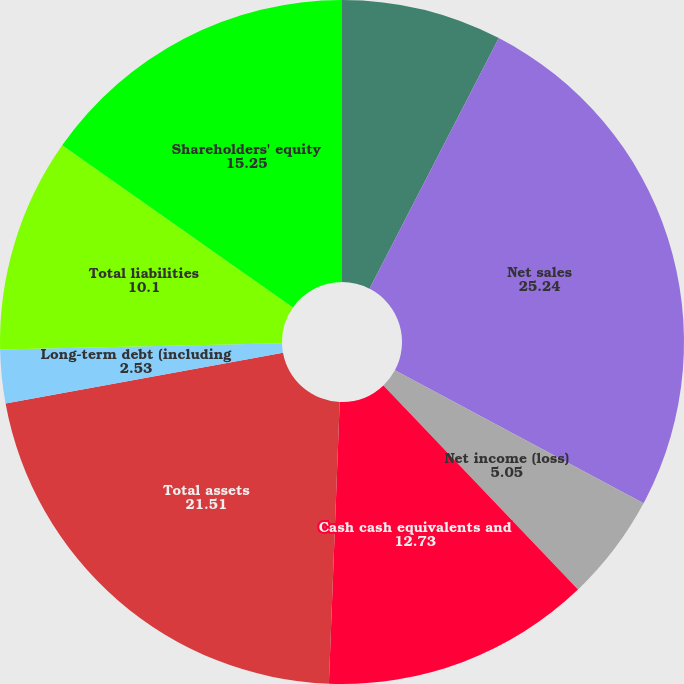Convert chart to OTSL. <chart><loc_0><loc_0><loc_500><loc_500><pie_chart><fcel>Five fiscal years ended<fcel>Net sales<fcel>Net income (loss)<fcel>Basic<fcel>Cash cash equivalents and<fcel>Total assets<fcel>Long-term debt (including<fcel>Total liabilities<fcel>Shareholders' equity<nl><fcel>7.58%<fcel>25.24%<fcel>5.05%<fcel>0.01%<fcel>12.73%<fcel>21.51%<fcel>2.53%<fcel>10.1%<fcel>15.25%<nl></chart> 